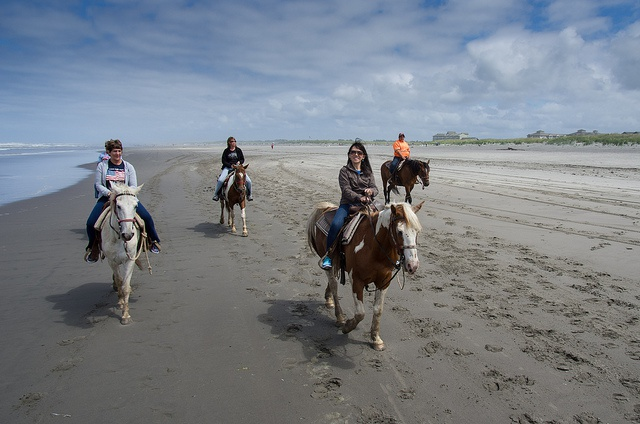Describe the objects in this image and their specific colors. I can see horse in blue, black, gray, and darkgray tones, horse in blue, gray, darkgray, black, and lightgray tones, people in blue, black, gray, and darkgray tones, people in blue, black, darkgray, gray, and navy tones, and horse in blue, black, gray, maroon, and darkgray tones in this image. 